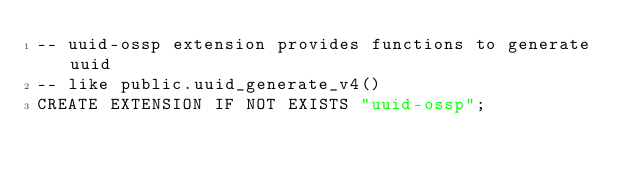Convert code to text. <code><loc_0><loc_0><loc_500><loc_500><_SQL_>-- uuid-ossp extension provides functions to generate uuid
-- like public.uuid_generate_v4()
CREATE EXTENSION IF NOT EXISTS "uuid-ossp";
</code> 